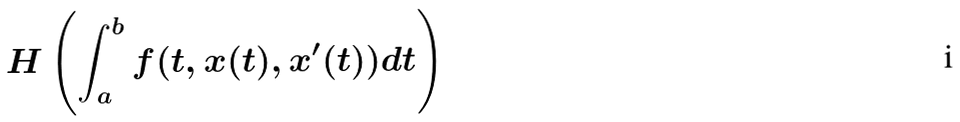Convert formula to latex. <formula><loc_0><loc_0><loc_500><loc_500>H \left ( \int _ { a } ^ { b } f ( t , x ( t ) , x ^ { \prime } ( t ) ) d t \right )</formula> 